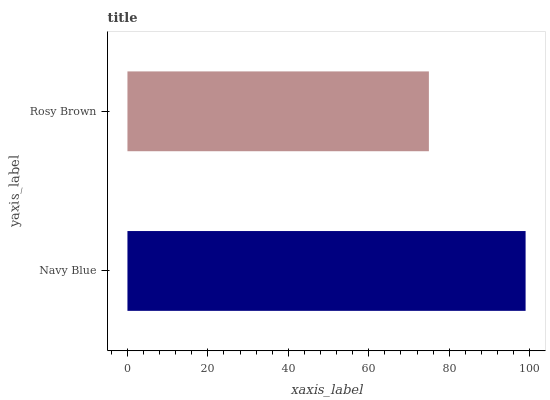Is Rosy Brown the minimum?
Answer yes or no. Yes. Is Navy Blue the maximum?
Answer yes or no. Yes. Is Rosy Brown the maximum?
Answer yes or no. No. Is Navy Blue greater than Rosy Brown?
Answer yes or no. Yes. Is Rosy Brown less than Navy Blue?
Answer yes or no. Yes. Is Rosy Brown greater than Navy Blue?
Answer yes or no. No. Is Navy Blue less than Rosy Brown?
Answer yes or no. No. Is Navy Blue the high median?
Answer yes or no. Yes. Is Rosy Brown the low median?
Answer yes or no. Yes. Is Rosy Brown the high median?
Answer yes or no. No. Is Navy Blue the low median?
Answer yes or no. No. 